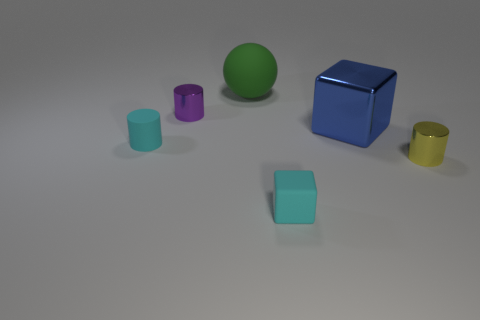Subtract all small shiny cylinders. How many cylinders are left? 1 Add 2 red cylinders. How many objects exist? 8 Subtract 1 cylinders. How many cylinders are left? 2 Subtract all balls. How many objects are left? 5 Subtract all blue cubes. How many cubes are left? 1 Subtract all gray blocks. Subtract all red cylinders. How many blocks are left? 2 Subtract all gray cylinders. How many red blocks are left? 0 Subtract all big balls. Subtract all gray shiny spheres. How many objects are left? 5 Add 1 shiny things. How many shiny things are left? 4 Add 1 tiny cylinders. How many tiny cylinders exist? 4 